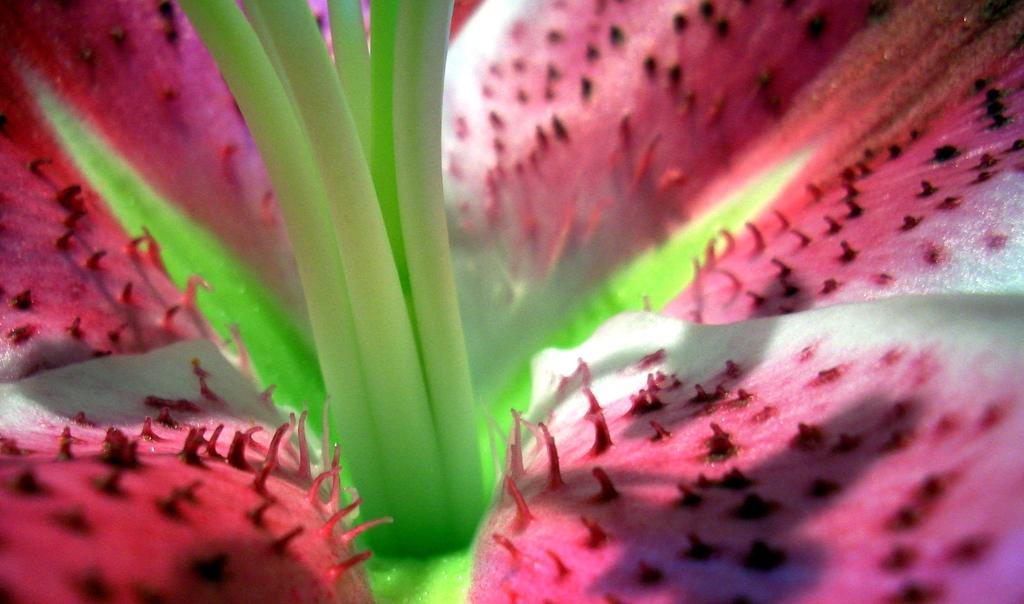What is present in the image? There is a flower in the image. Can you describe the flower in more detail? The flower has petals. What type of needle is being used to sew the flag in the image? There is no needle or flag present in the image; it only features a flower with petals. 